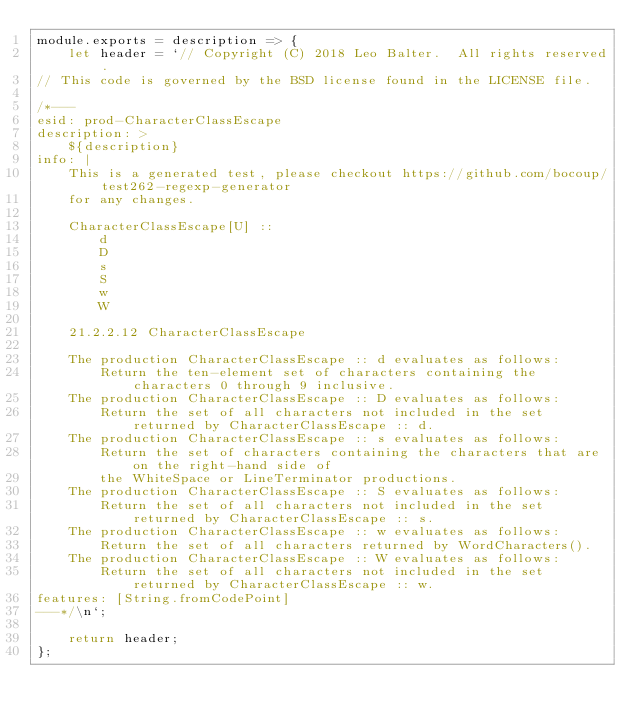<code> <loc_0><loc_0><loc_500><loc_500><_JavaScript_>module.exports = description => {
    let header = `// Copyright (C) 2018 Leo Balter.  All rights reserved.
// This code is governed by the BSD license found in the LICENSE file.

/*---
esid: prod-CharacterClassEscape
description: >
    ${description}
info: |
    This is a generated test, please checkout https://github.com/bocoup/test262-regexp-generator
    for any changes.

    CharacterClassEscape[U] ::
        d
        D
        s
        S
        w
        W

    21.2.2.12 CharacterClassEscape
    
    The production CharacterClassEscape :: d evaluates as follows:
        Return the ten-element set of characters containing the characters 0 through 9 inclusive.
    The production CharacterClassEscape :: D evaluates as follows:
        Return the set of all characters not included in the set returned by CharacterClassEscape :: d.
    The production CharacterClassEscape :: s evaluates as follows:
        Return the set of characters containing the characters that are on the right-hand side of
        the WhiteSpace or LineTerminator productions.
    The production CharacterClassEscape :: S evaluates as follows:
        Return the set of all characters not included in the set returned by CharacterClassEscape :: s.
    The production CharacterClassEscape :: w evaluates as follows:
        Return the set of all characters returned by WordCharacters().
    The production CharacterClassEscape :: W evaluates as follows:
        Return the set of all characters not included in the set returned by CharacterClassEscape :: w.
features: [String.fromCodePoint]
---*/\n`;

    return header;
};
</code> 